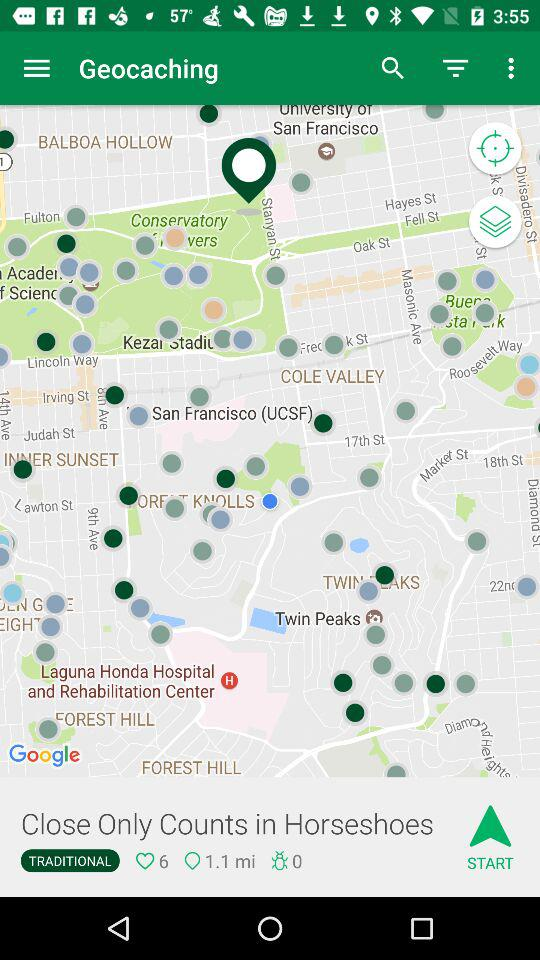How many more hearts are there than bugs?
Answer the question using a single word or phrase. 6 